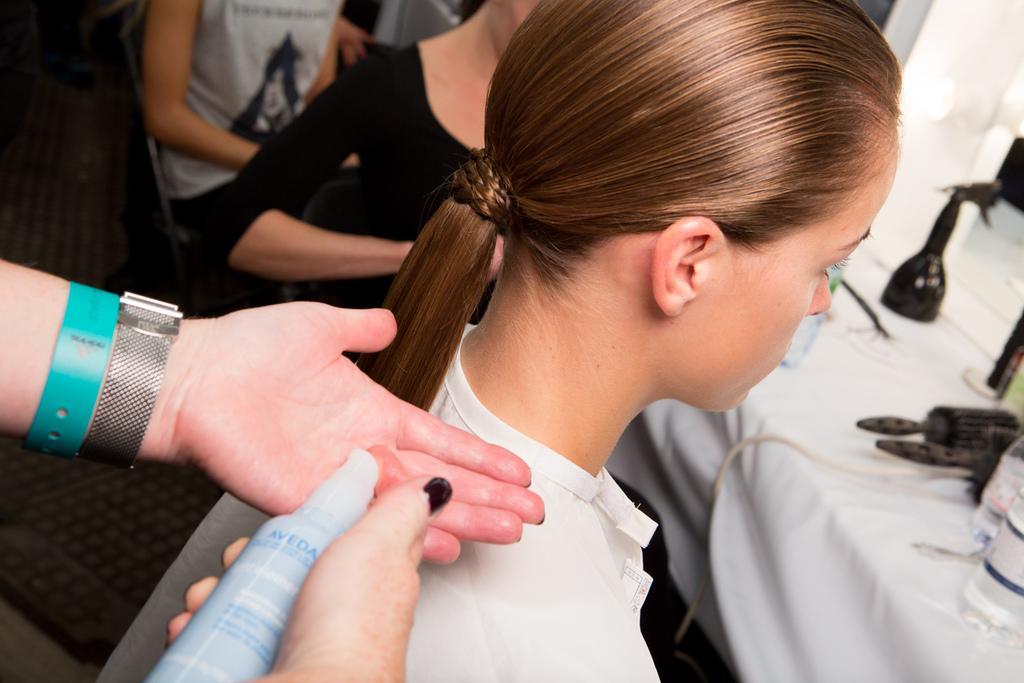In one or two sentences, can you explain what this image depicts? In this image we can see persons sitting on chairs and a table is in front of them. On the table there are tablecloth, plastic bottles and grooming kits. 